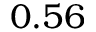Convert formula to latex. <formula><loc_0><loc_0><loc_500><loc_500>0 . 5 6</formula> 